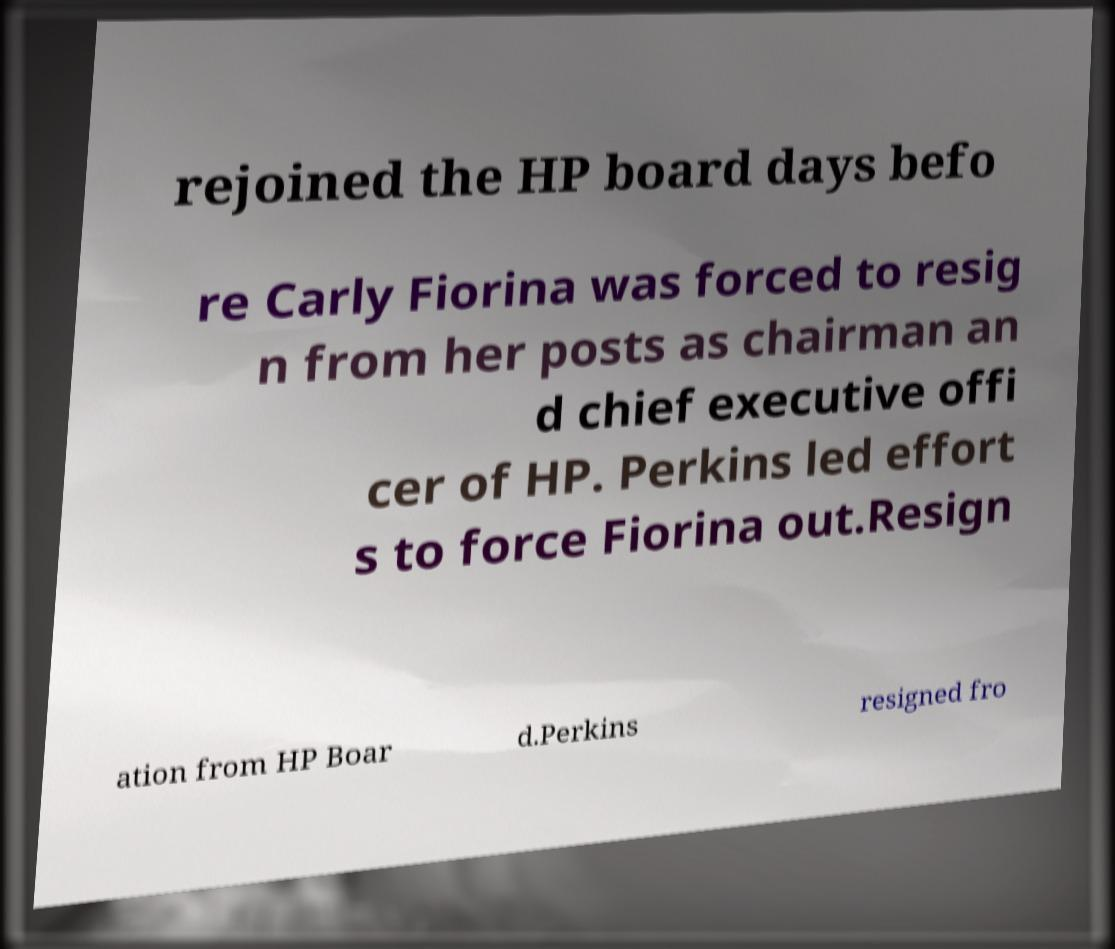Can you read and provide the text displayed in the image?This photo seems to have some interesting text. Can you extract and type it out for me? rejoined the HP board days befo re Carly Fiorina was forced to resig n from her posts as chairman an d chief executive offi cer of HP. Perkins led effort s to force Fiorina out.Resign ation from HP Boar d.Perkins resigned fro 